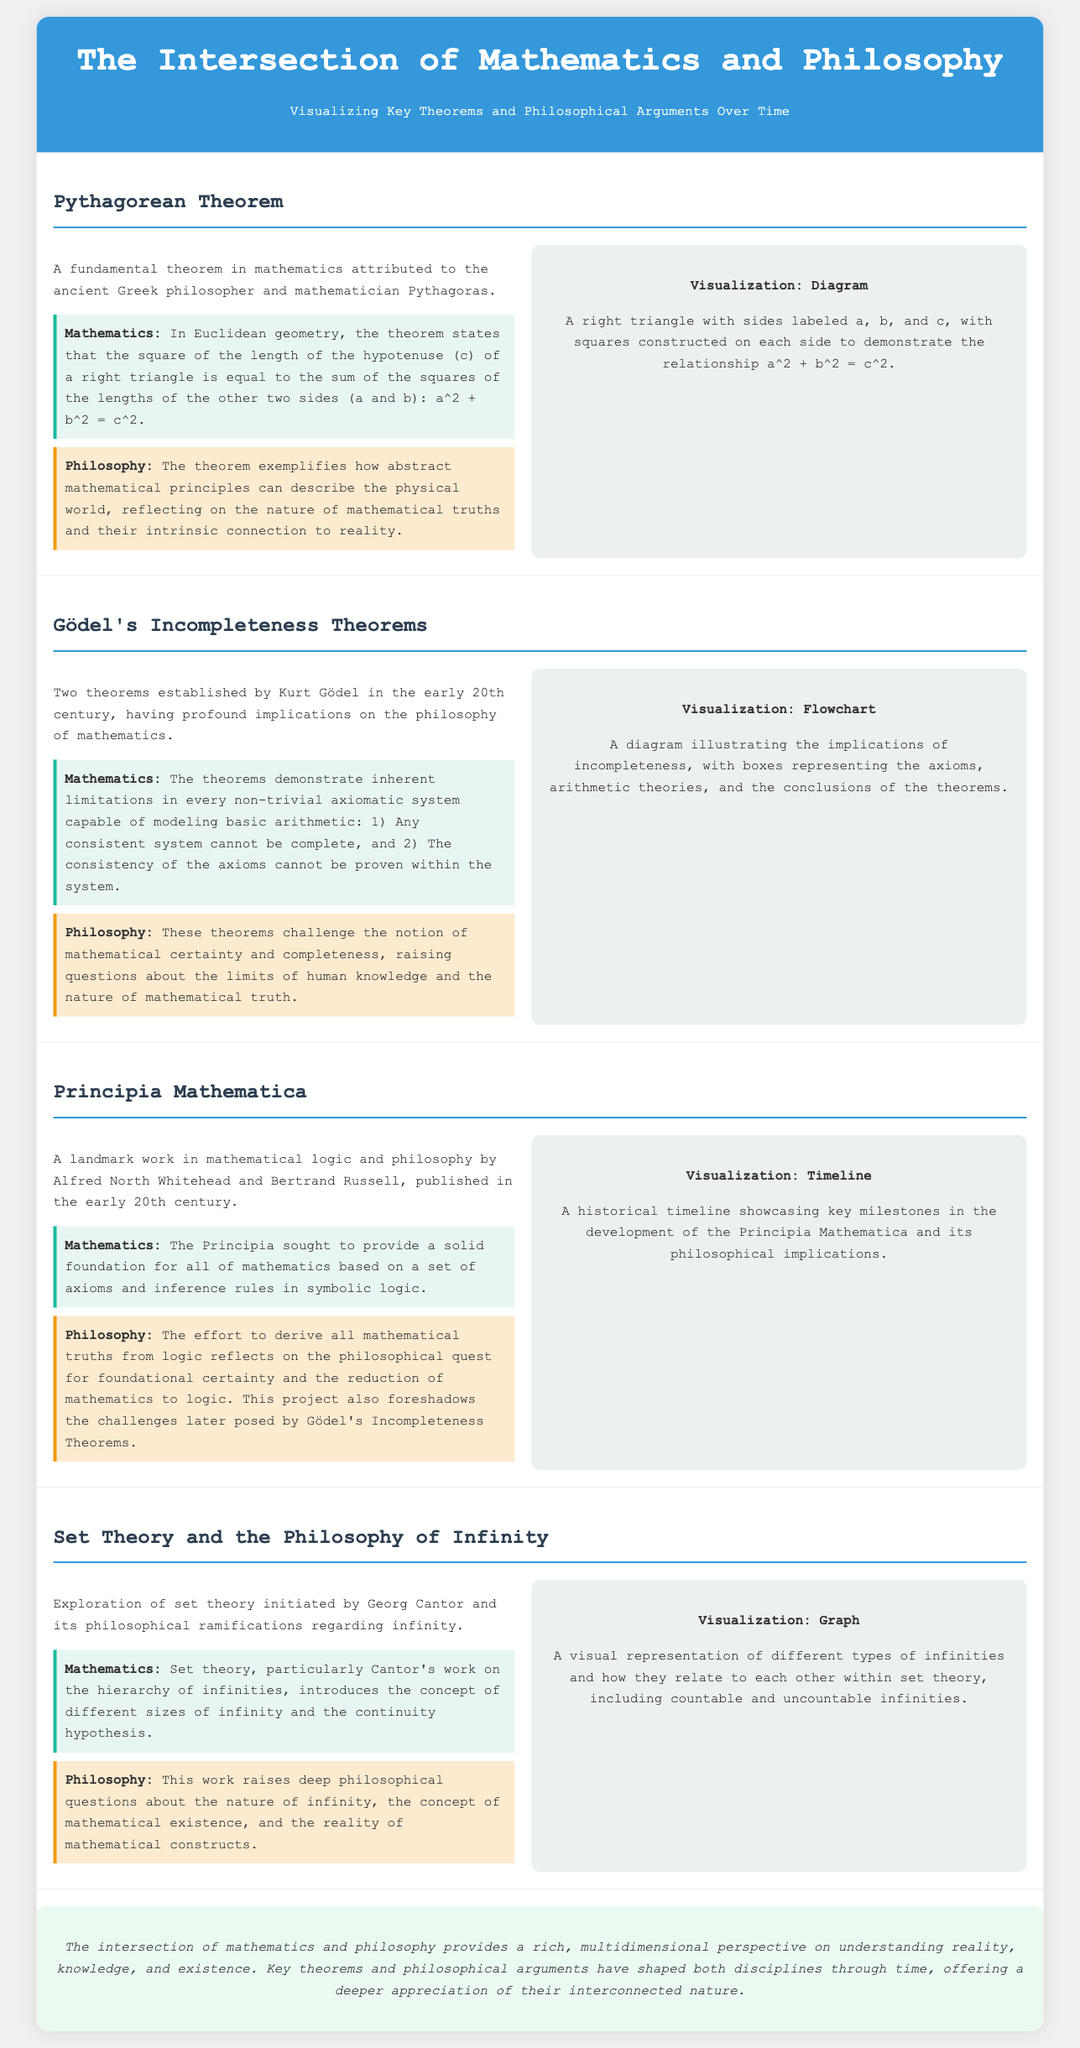What theorem is associated with Pythagoras? The document states that the theorem attributed to Pythagoras is a fundamental theorem in mathematics known as the Pythagorean Theorem.
Answer: Pythagorean Theorem What is the mathematical expression for the Pythagorean Theorem? The document outlines that the mathematical expression is a squared plus b squared equals c squared.
Answer: a² + b² = c² Who established Gödel's Incompleteness Theorems? The document indicates that Kurt Gödel established the Incompleteness Theorems in the early 20th century.
Answer: Kurt Gödel What does the Principia Mathematica aim to provide? According to the document, the Principia Mathematica sought to provide a solid foundation for all of mathematics.
Answer: A solid foundation for all mathematics Which philosophical concept does Cantor's set theory relate to? The document mentions that Cantor's set theory is related to the philosophical implications regarding infinity.
Answer: Infinity What type of visualization is used for Gödel's Incompleteness Theorems? The document describes the visualization for Gödel's Incompleteness Theorems as a flowchart.
Answer: Flowchart How many theorems are included in Gödel's work? The document states that there are two theorems established by Kurt Gödel.
Answer: Two What philosophical themes are raised by the Pythagorean Theorem? The document indicates that the Pythagorean Theorem reflects on the nature of mathematical truths and their intrinsic connection to reality.
Answer: Nature of mathematical truths What key philosophical question does set theory raise? According to the document, set theory raises deep philosophical questions about the nature of infinity.
Answer: Nature of infinity 